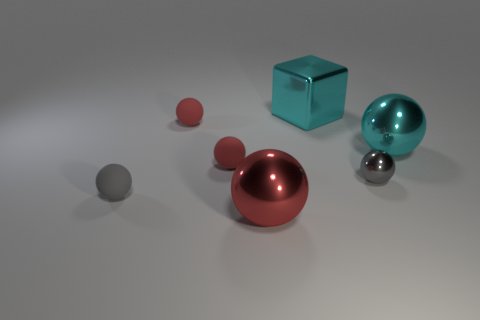Subtract all blue cylinders. How many red balls are left? 3 Subtract 3 spheres. How many spheres are left? 3 Subtract all red balls. How many balls are left? 3 Subtract all big red spheres. How many spheres are left? 5 Subtract all blue spheres. Subtract all gray cylinders. How many spheres are left? 6 Add 1 small gray rubber balls. How many objects exist? 8 Subtract all blocks. How many objects are left? 6 Add 7 small blue cylinders. How many small blue cylinders exist? 7 Subtract 2 red spheres. How many objects are left? 5 Subtract all big metallic blocks. Subtract all big cyan balls. How many objects are left? 5 